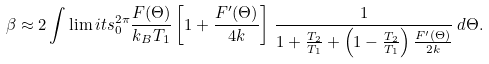Convert formula to latex. <formula><loc_0><loc_0><loc_500><loc_500>\beta \approx 2 \int \lim i t s _ { 0 } ^ { 2 \pi } \frac { F ( \Theta ) } { k _ { B } T _ { 1 } } \left [ 1 + \frac { F ^ { \prime } ( \Theta ) } { 4 k } \right ] \, \frac { 1 } { 1 + \frac { T _ { 2 } } { T _ { 1 } } + \left ( 1 - \frac { T _ { 2 } } { T _ { 1 } } \right ) \frac { F ^ { \prime } ( \Theta ) } { 2 k } } \, d \Theta .</formula> 